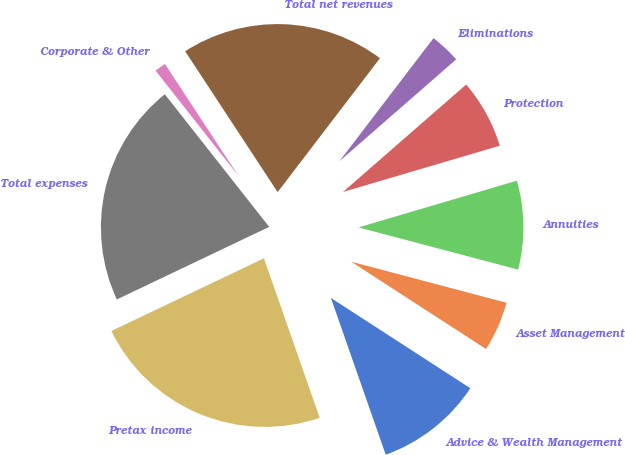Convert chart to OTSL. <chart><loc_0><loc_0><loc_500><loc_500><pie_chart><fcel>Advice & Wealth Management<fcel>Asset Management<fcel>Annuities<fcel>Protection<fcel>Eliminations<fcel>Total net revenues<fcel>Corporate & Other<fcel>Total expenses<fcel>Pretax income<nl><fcel>10.5%<fcel>5.03%<fcel>8.68%<fcel>6.85%<fcel>3.2%<fcel>19.63%<fcel>1.37%<fcel>21.46%<fcel>23.28%<nl></chart> 